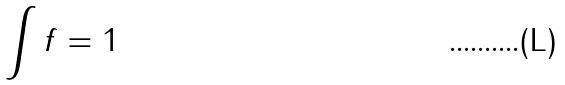<formula> <loc_0><loc_0><loc_500><loc_500>\int f = 1</formula> 